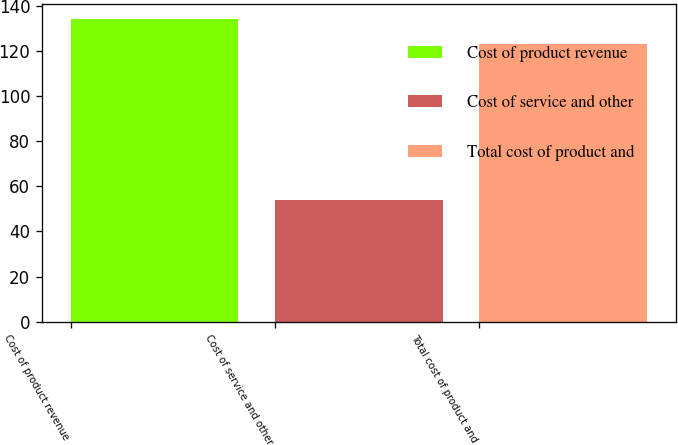<chart> <loc_0><loc_0><loc_500><loc_500><bar_chart><fcel>Cost of product revenue<fcel>Cost of service and other<fcel>Total cost of product and<nl><fcel>134<fcel>54<fcel>123<nl></chart> 